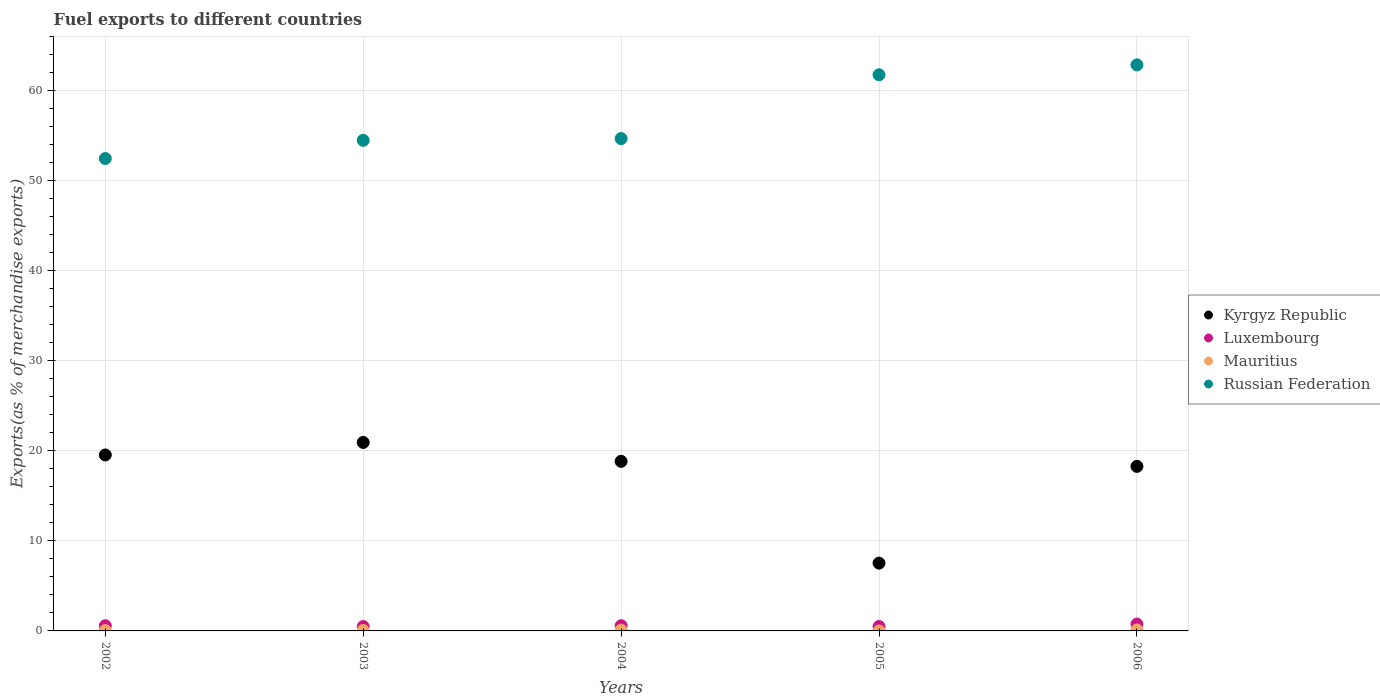How many different coloured dotlines are there?
Provide a short and direct response. 4. Is the number of dotlines equal to the number of legend labels?
Your answer should be compact. Yes. What is the percentage of exports to different countries in Mauritius in 2006?
Keep it short and to the point. 0.1. Across all years, what is the maximum percentage of exports to different countries in Luxembourg?
Provide a short and direct response. 0.76. Across all years, what is the minimum percentage of exports to different countries in Kyrgyz Republic?
Offer a terse response. 7.53. In which year was the percentage of exports to different countries in Luxembourg minimum?
Make the answer very short. 2003. What is the total percentage of exports to different countries in Russian Federation in the graph?
Offer a very short reply. 286.31. What is the difference between the percentage of exports to different countries in Russian Federation in 2004 and that in 2006?
Make the answer very short. -8.19. What is the difference between the percentage of exports to different countries in Mauritius in 2006 and the percentage of exports to different countries in Kyrgyz Republic in 2004?
Offer a very short reply. -18.73. What is the average percentage of exports to different countries in Russian Federation per year?
Give a very brief answer. 57.26. In the year 2002, what is the difference between the percentage of exports to different countries in Mauritius and percentage of exports to different countries in Kyrgyz Republic?
Keep it short and to the point. -19.5. What is the ratio of the percentage of exports to different countries in Mauritius in 2003 to that in 2006?
Provide a short and direct response. 0.5. Is the percentage of exports to different countries in Luxembourg in 2004 less than that in 2005?
Your response must be concise. No. What is the difference between the highest and the second highest percentage of exports to different countries in Luxembourg?
Offer a terse response. 0.19. What is the difference between the highest and the lowest percentage of exports to different countries in Mauritius?
Offer a very short reply. 0.1. In how many years, is the percentage of exports to different countries in Mauritius greater than the average percentage of exports to different countries in Mauritius taken over all years?
Make the answer very short. 2. Is it the case that in every year, the sum of the percentage of exports to different countries in Russian Federation and percentage of exports to different countries in Luxembourg  is greater than the percentage of exports to different countries in Mauritius?
Your answer should be very brief. Yes. Is the percentage of exports to different countries in Russian Federation strictly greater than the percentage of exports to different countries in Kyrgyz Republic over the years?
Your answer should be very brief. Yes. How many years are there in the graph?
Ensure brevity in your answer.  5. Does the graph contain grids?
Provide a succinct answer. Yes. How are the legend labels stacked?
Your answer should be very brief. Vertical. What is the title of the graph?
Offer a terse response. Fuel exports to different countries. What is the label or title of the Y-axis?
Make the answer very short. Exports(as % of merchandise exports). What is the Exports(as % of merchandise exports) of Kyrgyz Republic in 2002?
Make the answer very short. 19.55. What is the Exports(as % of merchandise exports) of Luxembourg in 2002?
Your answer should be very brief. 0.58. What is the Exports(as % of merchandise exports) in Mauritius in 2002?
Offer a terse response. 0.04. What is the Exports(as % of merchandise exports) of Russian Federation in 2002?
Offer a very short reply. 52.47. What is the Exports(as % of merchandise exports) in Kyrgyz Republic in 2003?
Your answer should be compact. 20.94. What is the Exports(as % of merchandise exports) of Luxembourg in 2003?
Offer a terse response. 0.49. What is the Exports(as % of merchandise exports) in Mauritius in 2003?
Keep it short and to the point. 0.05. What is the Exports(as % of merchandise exports) of Russian Federation in 2003?
Provide a succinct answer. 54.49. What is the Exports(as % of merchandise exports) of Kyrgyz Republic in 2004?
Keep it short and to the point. 18.84. What is the Exports(as % of merchandise exports) in Luxembourg in 2004?
Your response must be concise. 0.58. What is the Exports(as % of merchandise exports) of Mauritius in 2004?
Your answer should be compact. 0.09. What is the Exports(as % of merchandise exports) in Russian Federation in 2004?
Your answer should be compact. 54.69. What is the Exports(as % of merchandise exports) in Kyrgyz Republic in 2005?
Provide a succinct answer. 7.53. What is the Exports(as % of merchandise exports) of Luxembourg in 2005?
Offer a very short reply. 0.49. What is the Exports(as % of merchandise exports) in Mauritius in 2005?
Offer a very short reply. 0. What is the Exports(as % of merchandise exports) of Russian Federation in 2005?
Make the answer very short. 61.77. What is the Exports(as % of merchandise exports) of Kyrgyz Republic in 2006?
Your answer should be very brief. 18.28. What is the Exports(as % of merchandise exports) of Luxembourg in 2006?
Offer a terse response. 0.76. What is the Exports(as % of merchandise exports) of Mauritius in 2006?
Your response must be concise. 0.1. What is the Exports(as % of merchandise exports) in Russian Federation in 2006?
Your response must be concise. 62.88. Across all years, what is the maximum Exports(as % of merchandise exports) in Kyrgyz Republic?
Ensure brevity in your answer.  20.94. Across all years, what is the maximum Exports(as % of merchandise exports) in Luxembourg?
Provide a short and direct response. 0.76. Across all years, what is the maximum Exports(as % of merchandise exports) in Mauritius?
Your answer should be very brief. 0.1. Across all years, what is the maximum Exports(as % of merchandise exports) of Russian Federation?
Give a very brief answer. 62.88. Across all years, what is the minimum Exports(as % of merchandise exports) in Kyrgyz Republic?
Make the answer very short. 7.53. Across all years, what is the minimum Exports(as % of merchandise exports) in Luxembourg?
Provide a succinct answer. 0.49. Across all years, what is the minimum Exports(as % of merchandise exports) in Mauritius?
Provide a short and direct response. 0. Across all years, what is the minimum Exports(as % of merchandise exports) of Russian Federation?
Provide a succinct answer. 52.47. What is the total Exports(as % of merchandise exports) of Kyrgyz Republic in the graph?
Your response must be concise. 85.13. What is the total Exports(as % of merchandise exports) in Luxembourg in the graph?
Offer a very short reply. 2.9. What is the total Exports(as % of merchandise exports) in Mauritius in the graph?
Keep it short and to the point. 0.29. What is the total Exports(as % of merchandise exports) of Russian Federation in the graph?
Your answer should be compact. 286.31. What is the difference between the Exports(as % of merchandise exports) in Kyrgyz Republic in 2002 and that in 2003?
Provide a succinct answer. -1.39. What is the difference between the Exports(as % of merchandise exports) in Luxembourg in 2002 and that in 2003?
Offer a very short reply. 0.09. What is the difference between the Exports(as % of merchandise exports) in Mauritius in 2002 and that in 2003?
Give a very brief answer. -0.01. What is the difference between the Exports(as % of merchandise exports) in Russian Federation in 2002 and that in 2003?
Your response must be concise. -2.02. What is the difference between the Exports(as % of merchandise exports) in Kyrgyz Republic in 2002 and that in 2004?
Your response must be concise. 0.71. What is the difference between the Exports(as % of merchandise exports) of Mauritius in 2002 and that in 2004?
Your answer should be very brief. -0.04. What is the difference between the Exports(as % of merchandise exports) of Russian Federation in 2002 and that in 2004?
Give a very brief answer. -2.21. What is the difference between the Exports(as % of merchandise exports) of Kyrgyz Republic in 2002 and that in 2005?
Ensure brevity in your answer.  12.02. What is the difference between the Exports(as % of merchandise exports) in Luxembourg in 2002 and that in 2005?
Provide a short and direct response. 0.09. What is the difference between the Exports(as % of merchandise exports) of Mauritius in 2002 and that in 2005?
Give a very brief answer. 0.04. What is the difference between the Exports(as % of merchandise exports) in Russian Federation in 2002 and that in 2005?
Provide a short and direct response. -9.3. What is the difference between the Exports(as % of merchandise exports) in Kyrgyz Republic in 2002 and that in 2006?
Offer a terse response. 1.27. What is the difference between the Exports(as % of merchandise exports) in Luxembourg in 2002 and that in 2006?
Ensure brevity in your answer.  -0.19. What is the difference between the Exports(as % of merchandise exports) in Mauritius in 2002 and that in 2006?
Ensure brevity in your answer.  -0.06. What is the difference between the Exports(as % of merchandise exports) in Russian Federation in 2002 and that in 2006?
Provide a succinct answer. -10.4. What is the difference between the Exports(as % of merchandise exports) of Kyrgyz Republic in 2003 and that in 2004?
Your response must be concise. 2.1. What is the difference between the Exports(as % of merchandise exports) in Luxembourg in 2003 and that in 2004?
Your answer should be compact. -0.09. What is the difference between the Exports(as % of merchandise exports) of Mauritius in 2003 and that in 2004?
Your answer should be very brief. -0.04. What is the difference between the Exports(as % of merchandise exports) of Russian Federation in 2003 and that in 2004?
Your answer should be compact. -0.19. What is the difference between the Exports(as % of merchandise exports) of Kyrgyz Republic in 2003 and that in 2005?
Your answer should be compact. 13.4. What is the difference between the Exports(as % of merchandise exports) of Luxembourg in 2003 and that in 2005?
Your answer should be very brief. -0. What is the difference between the Exports(as % of merchandise exports) of Mauritius in 2003 and that in 2005?
Your response must be concise. 0.05. What is the difference between the Exports(as % of merchandise exports) in Russian Federation in 2003 and that in 2005?
Provide a succinct answer. -7.28. What is the difference between the Exports(as % of merchandise exports) in Kyrgyz Republic in 2003 and that in 2006?
Keep it short and to the point. 2.66. What is the difference between the Exports(as % of merchandise exports) in Luxembourg in 2003 and that in 2006?
Ensure brevity in your answer.  -0.28. What is the difference between the Exports(as % of merchandise exports) of Mauritius in 2003 and that in 2006?
Offer a terse response. -0.05. What is the difference between the Exports(as % of merchandise exports) in Russian Federation in 2003 and that in 2006?
Your answer should be compact. -8.38. What is the difference between the Exports(as % of merchandise exports) of Kyrgyz Republic in 2004 and that in 2005?
Make the answer very short. 11.3. What is the difference between the Exports(as % of merchandise exports) of Luxembourg in 2004 and that in 2005?
Provide a succinct answer. 0.09. What is the difference between the Exports(as % of merchandise exports) in Mauritius in 2004 and that in 2005?
Make the answer very short. 0.09. What is the difference between the Exports(as % of merchandise exports) of Russian Federation in 2004 and that in 2005?
Your answer should be very brief. -7.09. What is the difference between the Exports(as % of merchandise exports) in Kyrgyz Republic in 2004 and that in 2006?
Keep it short and to the point. 0.56. What is the difference between the Exports(as % of merchandise exports) in Luxembourg in 2004 and that in 2006?
Provide a succinct answer. -0.19. What is the difference between the Exports(as % of merchandise exports) of Mauritius in 2004 and that in 2006?
Make the answer very short. -0.02. What is the difference between the Exports(as % of merchandise exports) in Russian Federation in 2004 and that in 2006?
Offer a very short reply. -8.19. What is the difference between the Exports(as % of merchandise exports) in Kyrgyz Republic in 2005 and that in 2006?
Provide a succinct answer. -10.75. What is the difference between the Exports(as % of merchandise exports) of Luxembourg in 2005 and that in 2006?
Provide a succinct answer. -0.27. What is the difference between the Exports(as % of merchandise exports) in Mauritius in 2005 and that in 2006?
Give a very brief answer. -0.1. What is the difference between the Exports(as % of merchandise exports) in Russian Federation in 2005 and that in 2006?
Your answer should be very brief. -1.1. What is the difference between the Exports(as % of merchandise exports) of Kyrgyz Republic in 2002 and the Exports(as % of merchandise exports) of Luxembourg in 2003?
Offer a very short reply. 19.06. What is the difference between the Exports(as % of merchandise exports) of Kyrgyz Republic in 2002 and the Exports(as % of merchandise exports) of Mauritius in 2003?
Offer a very short reply. 19.5. What is the difference between the Exports(as % of merchandise exports) of Kyrgyz Republic in 2002 and the Exports(as % of merchandise exports) of Russian Federation in 2003?
Make the answer very short. -34.95. What is the difference between the Exports(as % of merchandise exports) in Luxembourg in 2002 and the Exports(as % of merchandise exports) in Mauritius in 2003?
Your answer should be compact. 0.53. What is the difference between the Exports(as % of merchandise exports) in Luxembourg in 2002 and the Exports(as % of merchandise exports) in Russian Federation in 2003?
Make the answer very short. -53.92. What is the difference between the Exports(as % of merchandise exports) of Mauritius in 2002 and the Exports(as % of merchandise exports) of Russian Federation in 2003?
Give a very brief answer. -54.45. What is the difference between the Exports(as % of merchandise exports) in Kyrgyz Republic in 2002 and the Exports(as % of merchandise exports) in Luxembourg in 2004?
Keep it short and to the point. 18.97. What is the difference between the Exports(as % of merchandise exports) in Kyrgyz Republic in 2002 and the Exports(as % of merchandise exports) in Mauritius in 2004?
Provide a short and direct response. 19.46. What is the difference between the Exports(as % of merchandise exports) in Kyrgyz Republic in 2002 and the Exports(as % of merchandise exports) in Russian Federation in 2004?
Make the answer very short. -35.14. What is the difference between the Exports(as % of merchandise exports) of Luxembourg in 2002 and the Exports(as % of merchandise exports) of Mauritius in 2004?
Make the answer very short. 0.49. What is the difference between the Exports(as % of merchandise exports) of Luxembourg in 2002 and the Exports(as % of merchandise exports) of Russian Federation in 2004?
Keep it short and to the point. -54.11. What is the difference between the Exports(as % of merchandise exports) in Mauritius in 2002 and the Exports(as % of merchandise exports) in Russian Federation in 2004?
Provide a succinct answer. -54.64. What is the difference between the Exports(as % of merchandise exports) in Kyrgyz Republic in 2002 and the Exports(as % of merchandise exports) in Luxembourg in 2005?
Your answer should be compact. 19.06. What is the difference between the Exports(as % of merchandise exports) in Kyrgyz Republic in 2002 and the Exports(as % of merchandise exports) in Mauritius in 2005?
Offer a very short reply. 19.55. What is the difference between the Exports(as % of merchandise exports) of Kyrgyz Republic in 2002 and the Exports(as % of merchandise exports) of Russian Federation in 2005?
Offer a terse response. -42.23. What is the difference between the Exports(as % of merchandise exports) in Luxembourg in 2002 and the Exports(as % of merchandise exports) in Mauritius in 2005?
Ensure brevity in your answer.  0.58. What is the difference between the Exports(as % of merchandise exports) in Luxembourg in 2002 and the Exports(as % of merchandise exports) in Russian Federation in 2005?
Provide a succinct answer. -61.2. What is the difference between the Exports(as % of merchandise exports) in Mauritius in 2002 and the Exports(as % of merchandise exports) in Russian Federation in 2005?
Ensure brevity in your answer.  -61.73. What is the difference between the Exports(as % of merchandise exports) of Kyrgyz Republic in 2002 and the Exports(as % of merchandise exports) of Luxembourg in 2006?
Provide a succinct answer. 18.78. What is the difference between the Exports(as % of merchandise exports) of Kyrgyz Republic in 2002 and the Exports(as % of merchandise exports) of Mauritius in 2006?
Keep it short and to the point. 19.44. What is the difference between the Exports(as % of merchandise exports) of Kyrgyz Republic in 2002 and the Exports(as % of merchandise exports) of Russian Federation in 2006?
Offer a very short reply. -43.33. What is the difference between the Exports(as % of merchandise exports) of Luxembourg in 2002 and the Exports(as % of merchandise exports) of Mauritius in 2006?
Your answer should be compact. 0.47. What is the difference between the Exports(as % of merchandise exports) of Luxembourg in 2002 and the Exports(as % of merchandise exports) of Russian Federation in 2006?
Provide a short and direct response. -62.3. What is the difference between the Exports(as % of merchandise exports) in Mauritius in 2002 and the Exports(as % of merchandise exports) in Russian Federation in 2006?
Provide a short and direct response. -62.83. What is the difference between the Exports(as % of merchandise exports) of Kyrgyz Republic in 2003 and the Exports(as % of merchandise exports) of Luxembourg in 2004?
Give a very brief answer. 20.36. What is the difference between the Exports(as % of merchandise exports) in Kyrgyz Republic in 2003 and the Exports(as % of merchandise exports) in Mauritius in 2004?
Provide a succinct answer. 20.85. What is the difference between the Exports(as % of merchandise exports) in Kyrgyz Republic in 2003 and the Exports(as % of merchandise exports) in Russian Federation in 2004?
Give a very brief answer. -33.75. What is the difference between the Exports(as % of merchandise exports) of Luxembourg in 2003 and the Exports(as % of merchandise exports) of Mauritius in 2004?
Make the answer very short. 0.4. What is the difference between the Exports(as % of merchandise exports) in Luxembourg in 2003 and the Exports(as % of merchandise exports) in Russian Federation in 2004?
Your answer should be very brief. -54.2. What is the difference between the Exports(as % of merchandise exports) in Mauritius in 2003 and the Exports(as % of merchandise exports) in Russian Federation in 2004?
Provide a short and direct response. -54.64. What is the difference between the Exports(as % of merchandise exports) in Kyrgyz Republic in 2003 and the Exports(as % of merchandise exports) in Luxembourg in 2005?
Your response must be concise. 20.45. What is the difference between the Exports(as % of merchandise exports) in Kyrgyz Republic in 2003 and the Exports(as % of merchandise exports) in Mauritius in 2005?
Make the answer very short. 20.93. What is the difference between the Exports(as % of merchandise exports) in Kyrgyz Republic in 2003 and the Exports(as % of merchandise exports) in Russian Federation in 2005?
Offer a terse response. -40.84. What is the difference between the Exports(as % of merchandise exports) of Luxembourg in 2003 and the Exports(as % of merchandise exports) of Mauritius in 2005?
Give a very brief answer. 0.49. What is the difference between the Exports(as % of merchandise exports) in Luxembourg in 2003 and the Exports(as % of merchandise exports) in Russian Federation in 2005?
Your answer should be compact. -61.29. What is the difference between the Exports(as % of merchandise exports) of Mauritius in 2003 and the Exports(as % of merchandise exports) of Russian Federation in 2005?
Offer a terse response. -61.72. What is the difference between the Exports(as % of merchandise exports) in Kyrgyz Republic in 2003 and the Exports(as % of merchandise exports) in Luxembourg in 2006?
Your response must be concise. 20.17. What is the difference between the Exports(as % of merchandise exports) of Kyrgyz Republic in 2003 and the Exports(as % of merchandise exports) of Mauritius in 2006?
Make the answer very short. 20.83. What is the difference between the Exports(as % of merchandise exports) of Kyrgyz Republic in 2003 and the Exports(as % of merchandise exports) of Russian Federation in 2006?
Give a very brief answer. -41.94. What is the difference between the Exports(as % of merchandise exports) of Luxembourg in 2003 and the Exports(as % of merchandise exports) of Mauritius in 2006?
Your response must be concise. 0.38. What is the difference between the Exports(as % of merchandise exports) in Luxembourg in 2003 and the Exports(as % of merchandise exports) in Russian Federation in 2006?
Provide a short and direct response. -62.39. What is the difference between the Exports(as % of merchandise exports) of Mauritius in 2003 and the Exports(as % of merchandise exports) of Russian Federation in 2006?
Your answer should be compact. -62.82. What is the difference between the Exports(as % of merchandise exports) of Kyrgyz Republic in 2004 and the Exports(as % of merchandise exports) of Luxembourg in 2005?
Offer a terse response. 18.35. What is the difference between the Exports(as % of merchandise exports) of Kyrgyz Republic in 2004 and the Exports(as % of merchandise exports) of Mauritius in 2005?
Offer a very short reply. 18.83. What is the difference between the Exports(as % of merchandise exports) of Kyrgyz Republic in 2004 and the Exports(as % of merchandise exports) of Russian Federation in 2005?
Offer a very short reply. -42.94. What is the difference between the Exports(as % of merchandise exports) in Luxembourg in 2004 and the Exports(as % of merchandise exports) in Mauritius in 2005?
Your answer should be very brief. 0.58. What is the difference between the Exports(as % of merchandise exports) of Luxembourg in 2004 and the Exports(as % of merchandise exports) of Russian Federation in 2005?
Ensure brevity in your answer.  -61.2. What is the difference between the Exports(as % of merchandise exports) in Mauritius in 2004 and the Exports(as % of merchandise exports) in Russian Federation in 2005?
Provide a short and direct response. -61.69. What is the difference between the Exports(as % of merchandise exports) of Kyrgyz Republic in 2004 and the Exports(as % of merchandise exports) of Luxembourg in 2006?
Provide a succinct answer. 18.07. What is the difference between the Exports(as % of merchandise exports) in Kyrgyz Republic in 2004 and the Exports(as % of merchandise exports) in Mauritius in 2006?
Your answer should be compact. 18.73. What is the difference between the Exports(as % of merchandise exports) in Kyrgyz Republic in 2004 and the Exports(as % of merchandise exports) in Russian Federation in 2006?
Give a very brief answer. -44.04. What is the difference between the Exports(as % of merchandise exports) of Luxembourg in 2004 and the Exports(as % of merchandise exports) of Mauritius in 2006?
Your answer should be compact. 0.47. What is the difference between the Exports(as % of merchandise exports) of Luxembourg in 2004 and the Exports(as % of merchandise exports) of Russian Federation in 2006?
Your answer should be very brief. -62.3. What is the difference between the Exports(as % of merchandise exports) in Mauritius in 2004 and the Exports(as % of merchandise exports) in Russian Federation in 2006?
Ensure brevity in your answer.  -62.79. What is the difference between the Exports(as % of merchandise exports) of Kyrgyz Republic in 2005 and the Exports(as % of merchandise exports) of Luxembourg in 2006?
Provide a succinct answer. 6.77. What is the difference between the Exports(as % of merchandise exports) of Kyrgyz Republic in 2005 and the Exports(as % of merchandise exports) of Mauritius in 2006?
Your answer should be very brief. 7.43. What is the difference between the Exports(as % of merchandise exports) in Kyrgyz Republic in 2005 and the Exports(as % of merchandise exports) in Russian Federation in 2006?
Give a very brief answer. -55.34. What is the difference between the Exports(as % of merchandise exports) of Luxembourg in 2005 and the Exports(as % of merchandise exports) of Mauritius in 2006?
Your answer should be very brief. 0.39. What is the difference between the Exports(as % of merchandise exports) of Luxembourg in 2005 and the Exports(as % of merchandise exports) of Russian Federation in 2006?
Your answer should be very brief. -62.39. What is the difference between the Exports(as % of merchandise exports) of Mauritius in 2005 and the Exports(as % of merchandise exports) of Russian Federation in 2006?
Offer a terse response. -62.87. What is the average Exports(as % of merchandise exports) of Kyrgyz Republic per year?
Keep it short and to the point. 17.03. What is the average Exports(as % of merchandise exports) in Luxembourg per year?
Keep it short and to the point. 0.58. What is the average Exports(as % of merchandise exports) of Mauritius per year?
Your answer should be compact. 0.06. What is the average Exports(as % of merchandise exports) of Russian Federation per year?
Keep it short and to the point. 57.26. In the year 2002, what is the difference between the Exports(as % of merchandise exports) of Kyrgyz Republic and Exports(as % of merchandise exports) of Luxembourg?
Offer a terse response. 18.97. In the year 2002, what is the difference between the Exports(as % of merchandise exports) in Kyrgyz Republic and Exports(as % of merchandise exports) in Mauritius?
Offer a terse response. 19.5. In the year 2002, what is the difference between the Exports(as % of merchandise exports) of Kyrgyz Republic and Exports(as % of merchandise exports) of Russian Federation?
Give a very brief answer. -32.93. In the year 2002, what is the difference between the Exports(as % of merchandise exports) in Luxembourg and Exports(as % of merchandise exports) in Mauritius?
Your answer should be compact. 0.53. In the year 2002, what is the difference between the Exports(as % of merchandise exports) in Luxembourg and Exports(as % of merchandise exports) in Russian Federation?
Ensure brevity in your answer.  -51.9. In the year 2002, what is the difference between the Exports(as % of merchandise exports) of Mauritius and Exports(as % of merchandise exports) of Russian Federation?
Keep it short and to the point. -52.43. In the year 2003, what is the difference between the Exports(as % of merchandise exports) of Kyrgyz Republic and Exports(as % of merchandise exports) of Luxembourg?
Offer a terse response. 20.45. In the year 2003, what is the difference between the Exports(as % of merchandise exports) in Kyrgyz Republic and Exports(as % of merchandise exports) in Mauritius?
Your response must be concise. 20.88. In the year 2003, what is the difference between the Exports(as % of merchandise exports) in Kyrgyz Republic and Exports(as % of merchandise exports) in Russian Federation?
Make the answer very short. -33.56. In the year 2003, what is the difference between the Exports(as % of merchandise exports) of Luxembourg and Exports(as % of merchandise exports) of Mauritius?
Ensure brevity in your answer.  0.44. In the year 2003, what is the difference between the Exports(as % of merchandise exports) of Luxembourg and Exports(as % of merchandise exports) of Russian Federation?
Make the answer very short. -54.01. In the year 2003, what is the difference between the Exports(as % of merchandise exports) in Mauritius and Exports(as % of merchandise exports) in Russian Federation?
Your answer should be compact. -54.44. In the year 2004, what is the difference between the Exports(as % of merchandise exports) of Kyrgyz Republic and Exports(as % of merchandise exports) of Luxembourg?
Make the answer very short. 18.26. In the year 2004, what is the difference between the Exports(as % of merchandise exports) in Kyrgyz Republic and Exports(as % of merchandise exports) in Mauritius?
Keep it short and to the point. 18.75. In the year 2004, what is the difference between the Exports(as % of merchandise exports) of Kyrgyz Republic and Exports(as % of merchandise exports) of Russian Federation?
Make the answer very short. -35.85. In the year 2004, what is the difference between the Exports(as % of merchandise exports) in Luxembourg and Exports(as % of merchandise exports) in Mauritius?
Give a very brief answer. 0.49. In the year 2004, what is the difference between the Exports(as % of merchandise exports) in Luxembourg and Exports(as % of merchandise exports) in Russian Federation?
Make the answer very short. -54.11. In the year 2004, what is the difference between the Exports(as % of merchandise exports) in Mauritius and Exports(as % of merchandise exports) in Russian Federation?
Offer a terse response. -54.6. In the year 2005, what is the difference between the Exports(as % of merchandise exports) in Kyrgyz Republic and Exports(as % of merchandise exports) in Luxembourg?
Offer a very short reply. 7.04. In the year 2005, what is the difference between the Exports(as % of merchandise exports) in Kyrgyz Republic and Exports(as % of merchandise exports) in Mauritius?
Give a very brief answer. 7.53. In the year 2005, what is the difference between the Exports(as % of merchandise exports) in Kyrgyz Republic and Exports(as % of merchandise exports) in Russian Federation?
Your answer should be very brief. -54.24. In the year 2005, what is the difference between the Exports(as % of merchandise exports) of Luxembourg and Exports(as % of merchandise exports) of Mauritius?
Provide a succinct answer. 0.49. In the year 2005, what is the difference between the Exports(as % of merchandise exports) of Luxembourg and Exports(as % of merchandise exports) of Russian Federation?
Keep it short and to the point. -61.28. In the year 2005, what is the difference between the Exports(as % of merchandise exports) of Mauritius and Exports(as % of merchandise exports) of Russian Federation?
Offer a very short reply. -61.77. In the year 2006, what is the difference between the Exports(as % of merchandise exports) in Kyrgyz Republic and Exports(as % of merchandise exports) in Luxembourg?
Provide a succinct answer. 17.51. In the year 2006, what is the difference between the Exports(as % of merchandise exports) in Kyrgyz Republic and Exports(as % of merchandise exports) in Mauritius?
Offer a terse response. 18.17. In the year 2006, what is the difference between the Exports(as % of merchandise exports) of Kyrgyz Republic and Exports(as % of merchandise exports) of Russian Federation?
Give a very brief answer. -44.6. In the year 2006, what is the difference between the Exports(as % of merchandise exports) in Luxembourg and Exports(as % of merchandise exports) in Mauritius?
Keep it short and to the point. 0.66. In the year 2006, what is the difference between the Exports(as % of merchandise exports) in Luxembourg and Exports(as % of merchandise exports) in Russian Federation?
Offer a terse response. -62.11. In the year 2006, what is the difference between the Exports(as % of merchandise exports) of Mauritius and Exports(as % of merchandise exports) of Russian Federation?
Make the answer very short. -62.77. What is the ratio of the Exports(as % of merchandise exports) of Kyrgyz Republic in 2002 to that in 2003?
Offer a terse response. 0.93. What is the ratio of the Exports(as % of merchandise exports) in Luxembourg in 2002 to that in 2003?
Offer a terse response. 1.18. What is the ratio of the Exports(as % of merchandise exports) of Mauritius in 2002 to that in 2003?
Keep it short and to the point. 0.83. What is the ratio of the Exports(as % of merchandise exports) of Russian Federation in 2002 to that in 2003?
Keep it short and to the point. 0.96. What is the ratio of the Exports(as % of merchandise exports) in Kyrgyz Republic in 2002 to that in 2004?
Give a very brief answer. 1.04. What is the ratio of the Exports(as % of merchandise exports) of Luxembourg in 2002 to that in 2004?
Offer a very short reply. 1. What is the ratio of the Exports(as % of merchandise exports) of Mauritius in 2002 to that in 2004?
Give a very brief answer. 0.49. What is the ratio of the Exports(as % of merchandise exports) in Russian Federation in 2002 to that in 2004?
Provide a short and direct response. 0.96. What is the ratio of the Exports(as % of merchandise exports) of Kyrgyz Republic in 2002 to that in 2005?
Provide a succinct answer. 2.6. What is the ratio of the Exports(as % of merchandise exports) of Luxembourg in 2002 to that in 2005?
Make the answer very short. 1.18. What is the ratio of the Exports(as % of merchandise exports) in Mauritius in 2002 to that in 2005?
Offer a very short reply. 66. What is the ratio of the Exports(as % of merchandise exports) of Russian Federation in 2002 to that in 2005?
Make the answer very short. 0.85. What is the ratio of the Exports(as % of merchandise exports) of Kyrgyz Republic in 2002 to that in 2006?
Offer a very short reply. 1.07. What is the ratio of the Exports(as % of merchandise exports) of Luxembourg in 2002 to that in 2006?
Provide a short and direct response. 0.76. What is the ratio of the Exports(as % of merchandise exports) in Mauritius in 2002 to that in 2006?
Offer a very short reply. 0.41. What is the ratio of the Exports(as % of merchandise exports) in Russian Federation in 2002 to that in 2006?
Your answer should be very brief. 0.83. What is the ratio of the Exports(as % of merchandise exports) of Kyrgyz Republic in 2003 to that in 2004?
Make the answer very short. 1.11. What is the ratio of the Exports(as % of merchandise exports) of Luxembourg in 2003 to that in 2004?
Make the answer very short. 0.85. What is the ratio of the Exports(as % of merchandise exports) of Mauritius in 2003 to that in 2004?
Keep it short and to the point. 0.59. What is the ratio of the Exports(as % of merchandise exports) in Russian Federation in 2003 to that in 2004?
Offer a very short reply. 1. What is the ratio of the Exports(as % of merchandise exports) in Kyrgyz Republic in 2003 to that in 2005?
Your response must be concise. 2.78. What is the ratio of the Exports(as % of merchandise exports) of Mauritius in 2003 to that in 2005?
Offer a terse response. 79.07. What is the ratio of the Exports(as % of merchandise exports) in Russian Federation in 2003 to that in 2005?
Your answer should be compact. 0.88. What is the ratio of the Exports(as % of merchandise exports) in Kyrgyz Republic in 2003 to that in 2006?
Your answer should be very brief. 1.15. What is the ratio of the Exports(as % of merchandise exports) in Luxembourg in 2003 to that in 2006?
Make the answer very short. 0.64. What is the ratio of the Exports(as % of merchandise exports) of Mauritius in 2003 to that in 2006?
Give a very brief answer. 0.5. What is the ratio of the Exports(as % of merchandise exports) in Russian Federation in 2003 to that in 2006?
Your answer should be compact. 0.87. What is the ratio of the Exports(as % of merchandise exports) of Kyrgyz Republic in 2004 to that in 2005?
Provide a short and direct response. 2.5. What is the ratio of the Exports(as % of merchandise exports) in Luxembourg in 2004 to that in 2005?
Your answer should be compact. 1.18. What is the ratio of the Exports(as % of merchandise exports) of Mauritius in 2004 to that in 2005?
Provide a short and direct response. 134.83. What is the ratio of the Exports(as % of merchandise exports) of Russian Federation in 2004 to that in 2005?
Your answer should be very brief. 0.89. What is the ratio of the Exports(as % of merchandise exports) of Kyrgyz Republic in 2004 to that in 2006?
Provide a short and direct response. 1.03. What is the ratio of the Exports(as % of merchandise exports) in Luxembourg in 2004 to that in 2006?
Make the answer very short. 0.75. What is the ratio of the Exports(as % of merchandise exports) of Mauritius in 2004 to that in 2006?
Offer a very short reply. 0.85. What is the ratio of the Exports(as % of merchandise exports) of Russian Federation in 2004 to that in 2006?
Keep it short and to the point. 0.87. What is the ratio of the Exports(as % of merchandise exports) in Kyrgyz Republic in 2005 to that in 2006?
Offer a very short reply. 0.41. What is the ratio of the Exports(as % of merchandise exports) in Luxembourg in 2005 to that in 2006?
Your answer should be compact. 0.64. What is the ratio of the Exports(as % of merchandise exports) of Mauritius in 2005 to that in 2006?
Offer a very short reply. 0.01. What is the ratio of the Exports(as % of merchandise exports) in Russian Federation in 2005 to that in 2006?
Your response must be concise. 0.98. What is the difference between the highest and the second highest Exports(as % of merchandise exports) in Kyrgyz Republic?
Offer a very short reply. 1.39. What is the difference between the highest and the second highest Exports(as % of merchandise exports) of Luxembourg?
Provide a succinct answer. 0.19. What is the difference between the highest and the second highest Exports(as % of merchandise exports) of Mauritius?
Provide a short and direct response. 0.02. What is the difference between the highest and the second highest Exports(as % of merchandise exports) in Russian Federation?
Give a very brief answer. 1.1. What is the difference between the highest and the lowest Exports(as % of merchandise exports) in Kyrgyz Republic?
Your answer should be very brief. 13.4. What is the difference between the highest and the lowest Exports(as % of merchandise exports) in Luxembourg?
Your answer should be compact. 0.28. What is the difference between the highest and the lowest Exports(as % of merchandise exports) of Mauritius?
Your response must be concise. 0.1. What is the difference between the highest and the lowest Exports(as % of merchandise exports) in Russian Federation?
Ensure brevity in your answer.  10.4. 